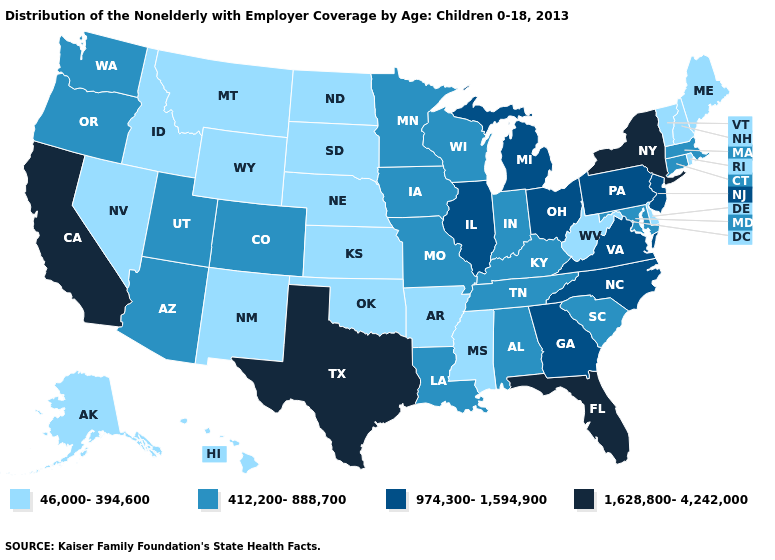Name the states that have a value in the range 974,300-1,594,900?
Quick response, please. Georgia, Illinois, Michigan, New Jersey, North Carolina, Ohio, Pennsylvania, Virginia. What is the highest value in the USA?
Write a very short answer. 1,628,800-4,242,000. What is the value of Wisconsin?
Short answer required. 412,200-888,700. How many symbols are there in the legend?
Quick response, please. 4. Does Tennessee have the lowest value in the USA?
Be succinct. No. Among the states that border Ohio , which have the highest value?
Keep it brief. Michigan, Pennsylvania. Which states have the lowest value in the USA?
Write a very short answer. Alaska, Arkansas, Delaware, Hawaii, Idaho, Kansas, Maine, Mississippi, Montana, Nebraska, Nevada, New Hampshire, New Mexico, North Dakota, Oklahoma, Rhode Island, South Dakota, Vermont, West Virginia, Wyoming. What is the highest value in the USA?
Give a very brief answer. 1,628,800-4,242,000. What is the value of New Jersey?
Concise answer only. 974,300-1,594,900. What is the lowest value in the USA?
Short answer required. 46,000-394,600. What is the value of North Dakota?
Quick response, please. 46,000-394,600. Which states have the lowest value in the USA?
Short answer required. Alaska, Arkansas, Delaware, Hawaii, Idaho, Kansas, Maine, Mississippi, Montana, Nebraska, Nevada, New Hampshire, New Mexico, North Dakota, Oklahoma, Rhode Island, South Dakota, Vermont, West Virginia, Wyoming. Does the first symbol in the legend represent the smallest category?
Give a very brief answer. Yes. Name the states that have a value in the range 46,000-394,600?
Write a very short answer. Alaska, Arkansas, Delaware, Hawaii, Idaho, Kansas, Maine, Mississippi, Montana, Nebraska, Nevada, New Hampshire, New Mexico, North Dakota, Oklahoma, Rhode Island, South Dakota, Vermont, West Virginia, Wyoming. Does Mississippi have the lowest value in the South?
Quick response, please. Yes. 